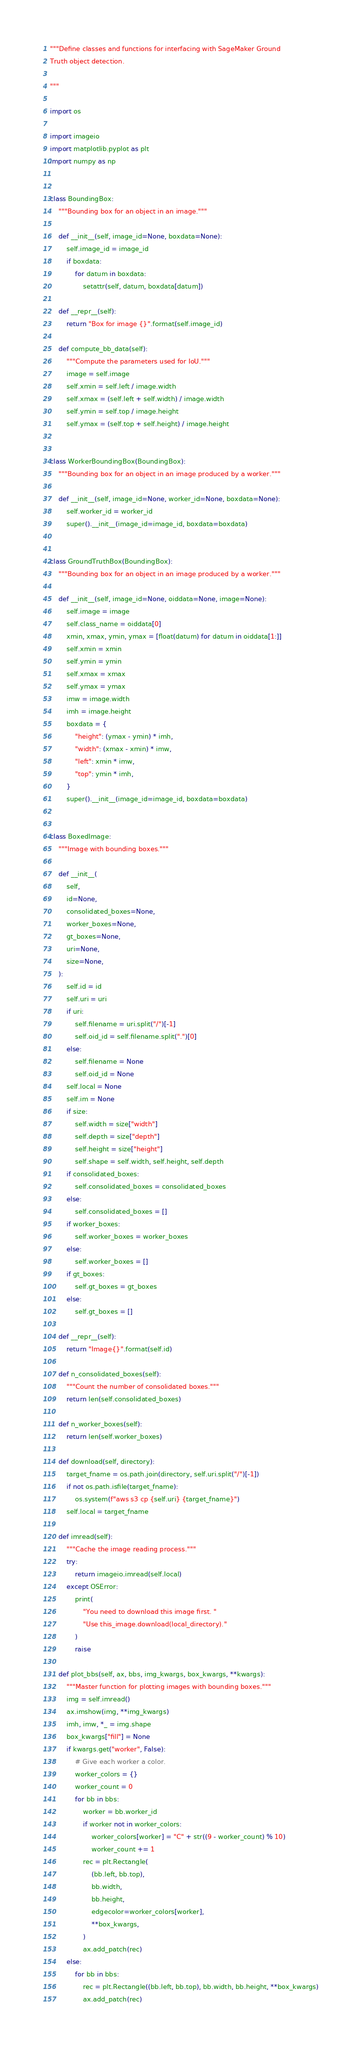<code> <loc_0><loc_0><loc_500><loc_500><_Python_>"""Define classes and functions for interfacing with SageMaker Ground
Truth object detection.

"""

import os

import imageio
import matplotlib.pyplot as plt
import numpy as np


class BoundingBox:
    """Bounding box for an object in an image."""

    def __init__(self, image_id=None, boxdata=None):
        self.image_id = image_id
        if boxdata:
            for datum in boxdata:
                setattr(self, datum, boxdata[datum])

    def __repr__(self):
        return "Box for image {}".format(self.image_id)

    def compute_bb_data(self):
        """Compute the parameters used for IoU."""
        image = self.image
        self.xmin = self.left / image.width
        self.xmax = (self.left + self.width) / image.width
        self.ymin = self.top / image.height
        self.ymax = (self.top + self.height) / image.height


class WorkerBoundingBox(BoundingBox):
    """Bounding box for an object in an image produced by a worker."""

    def __init__(self, image_id=None, worker_id=None, boxdata=None):
        self.worker_id = worker_id
        super().__init__(image_id=image_id, boxdata=boxdata)


class GroundTruthBox(BoundingBox):
    """Bounding box for an object in an image produced by a worker."""

    def __init__(self, image_id=None, oiddata=None, image=None):
        self.image = image
        self.class_name = oiddata[0]
        xmin, xmax, ymin, ymax = [float(datum) for datum in oiddata[1:]]
        self.xmin = xmin
        self.ymin = ymin
        self.xmax = xmax
        self.ymax = ymax
        imw = image.width
        imh = image.height
        boxdata = {
            "height": (ymax - ymin) * imh,
            "width": (xmax - xmin) * imw,
            "left": xmin * imw,
            "top": ymin * imh,
        }
        super().__init__(image_id=image_id, boxdata=boxdata)


class BoxedImage:
    """Image with bounding boxes."""

    def __init__(
        self,
        id=None,
        consolidated_boxes=None,
        worker_boxes=None,
        gt_boxes=None,
        uri=None,
        size=None,
    ):
        self.id = id
        self.uri = uri
        if uri:
            self.filename = uri.split("/")[-1]
            self.oid_id = self.filename.split(".")[0]
        else:
            self.filename = None
            self.oid_id = None
        self.local = None
        self.im = None
        if size:
            self.width = size["width"]
            self.depth = size["depth"]
            self.height = size["height"]
            self.shape = self.width, self.height, self.depth
        if consolidated_boxes:
            self.consolidated_boxes = consolidated_boxes
        else:
            self.consolidated_boxes = []
        if worker_boxes:
            self.worker_boxes = worker_boxes
        else:
            self.worker_boxes = []
        if gt_boxes:
            self.gt_boxes = gt_boxes
        else:
            self.gt_boxes = []

    def __repr__(self):
        return "Image{}".format(self.id)

    def n_consolidated_boxes(self):
        """Count the number of consolidated boxes."""
        return len(self.consolidated_boxes)

    def n_worker_boxes(self):
        return len(self.worker_boxes)

    def download(self, directory):
        target_fname = os.path.join(directory, self.uri.split("/")[-1])
        if not os.path.isfile(target_fname):
            os.system(f"aws s3 cp {self.uri} {target_fname}")
        self.local = target_fname

    def imread(self):
        """Cache the image reading process."""
        try:
            return imageio.imread(self.local)
        except OSError:
            print(
                "You need to download this image first. "
                "Use this_image.download(local_directory)."
            )
            raise

    def plot_bbs(self, ax, bbs, img_kwargs, box_kwargs, **kwargs):
        """Master function for plotting images with bounding boxes."""
        img = self.imread()
        ax.imshow(img, **img_kwargs)
        imh, imw, *_ = img.shape
        box_kwargs["fill"] = None
        if kwargs.get("worker", False):
            # Give each worker a color.
            worker_colors = {}
            worker_count = 0
            for bb in bbs:
                worker = bb.worker_id
                if worker not in worker_colors:
                    worker_colors[worker] = "C" + str((9 - worker_count) % 10)
                    worker_count += 1
                rec = plt.Rectangle(
                    (bb.left, bb.top),
                    bb.width,
                    bb.height,
                    edgecolor=worker_colors[worker],
                    **box_kwargs,
                )
                ax.add_patch(rec)
        else:
            for bb in bbs:
                rec = plt.Rectangle((bb.left, bb.top), bb.width, bb.height, **box_kwargs)
                ax.add_patch(rec)</code> 